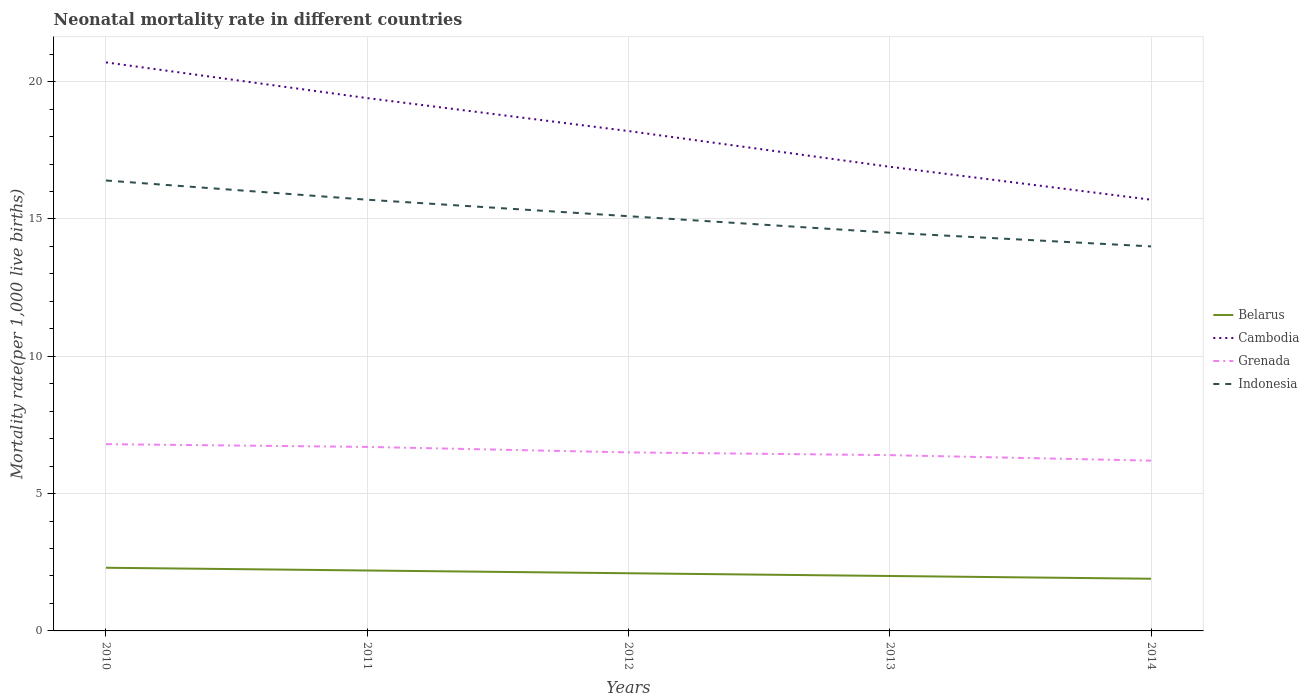How many different coloured lines are there?
Provide a succinct answer. 4. Across all years, what is the maximum neonatal mortality rate in Belarus?
Your answer should be compact. 1.9. In which year was the neonatal mortality rate in Grenada maximum?
Your response must be concise. 2014. What is the total neonatal mortality rate in Belarus in the graph?
Ensure brevity in your answer.  0.4. What is the difference between the highest and the second highest neonatal mortality rate in Grenada?
Give a very brief answer. 0.6. Is the neonatal mortality rate in Grenada strictly greater than the neonatal mortality rate in Indonesia over the years?
Offer a very short reply. Yes. What is the difference between two consecutive major ticks on the Y-axis?
Your answer should be very brief. 5. Are the values on the major ticks of Y-axis written in scientific E-notation?
Ensure brevity in your answer.  No. How many legend labels are there?
Keep it short and to the point. 4. How are the legend labels stacked?
Your answer should be very brief. Vertical. What is the title of the graph?
Provide a short and direct response. Neonatal mortality rate in different countries. Does "Tuvalu" appear as one of the legend labels in the graph?
Offer a terse response. No. What is the label or title of the Y-axis?
Your answer should be compact. Mortality rate(per 1,0 live births). What is the Mortality rate(per 1,000 live births) in Cambodia in 2010?
Your response must be concise. 20.7. What is the Mortality rate(per 1,000 live births) of Belarus in 2011?
Provide a short and direct response. 2.2. What is the Mortality rate(per 1,000 live births) in Grenada in 2011?
Offer a very short reply. 6.7. What is the Mortality rate(per 1,000 live births) of Indonesia in 2011?
Offer a very short reply. 15.7. What is the Mortality rate(per 1,000 live births) in Cambodia in 2012?
Make the answer very short. 18.2. What is the Mortality rate(per 1,000 live births) of Indonesia in 2012?
Give a very brief answer. 15.1. What is the Mortality rate(per 1,000 live births) in Belarus in 2013?
Keep it short and to the point. 2. What is the Mortality rate(per 1,000 live births) of Grenada in 2013?
Make the answer very short. 6.4. What is the Mortality rate(per 1,000 live births) in Cambodia in 2014?
Offer a very short reply. 15.7. Across all years, what is the maximum Mortality rate(per 1,000 live births) of Cambodia?
Your response must be concise. 20.7. Across all years, what is the minimum Mortality rate(per 1,000 live births) in Cambodia?
Give a very brief answer. 15.7. Across all years, what is the minimum Mortality rate(per 1,000 live births) of Grenada?
Offer a very short reply. 6.2. Across all years, what is the minimum Mortality rate(per 1,000 live births) of Indonesia?
Keep it short and to the point. 14. What is the total Mortality rate(per 1,000 live births) in Cambodia in the graph?
Your answer should be compact. 90.9. What is the total Mortality rate(per 1,000 live births) of Grenada in the graph?
Keep it short and to the point. 32.6. What is the total Mortality rate(per 1,000 live births) of Indonesia in the graph?
Provide a succinct answer. 75.7. What is the difference between the Mortality rate(per 1,000 live births) of Cambodia in 2010 and that in 2011?
Provide a succinct answer. 1.3. What is the difference between the Mortality rate(per 1,000 live births) in Indonesia in 2010 and that in 2011?
Offer a terse response. 0.7. What is the difference between the Mortality rate(per 1,000 live births) of Belarus in 2010 and that in 2012?
Ensure brevity in your answer.  0.2. What is the difference between the Mortality rate(per 1,000 live births) in Grenada in 2010 and that in 2012?
Provide a succinct answer. 0.3. What is the difference between the Mortality rate(per 1,000 live births) in Indonesia in 2010 and that in 2013?
Provide a short and direct response. 1.9. What is the difference between the Mortality rate(per 1,000 live births) in Indonesia in 2010 and that in 2014?
Ensure brevity in your answer.  2.4. What is the difference between the Mortality rate(per 1,000 live births) in Belarus in 2011 and that in 2013?
Provide a succinct answer. 0.2. What is the difference between the Mortality rate(per 1,000 live births) of Cambodia in 2011 and that in 2013?
Provide a succinct answer. 2.5. What is the difference between the Mortality rate(per 1,000 live births) of Indonesia in 2011 and that in 2013?
Your answer should be compact. 1.2. What is the difference between the Mortality rate(per 1,000 live births) in Belarus in 2011 and that in 2014?
Make the answer very short. 0.3. What is the difference between the Mortality rate(per 1,000 live births) of Cambodia in 2011 and that in 2014?
Your answer should be compact. 3.7. What is the difference between the Mortality rate(per 1,000 live births) of Indonesia in 2011 and that in 2014?
Give a very brief answer. 1.7. What is the difference between the Mortality rate(per 1,000 live births) in Cambodia in 2012 and that in 2013?
Offer a terse response. 1.3. What is the difference between the Mortality rate(per 1,000 live births) of Grenada in 2012 and that in 2013?
Make the answer very short. 0.1. What is the difference between the Mortality rate(per 1,000 live births) in Indonesia in 2012 and that in 2013?
Provide a succinct answer. 0.6. What is the difference between the Mortality rate(per 1,000 live births) of Cambodia in 2012 and that in 2014?
Provide a short and direct response. 2.5. What is the difference between the Mortality rate(per 1,000 live births) of Grenada in 2012 and that in 2014?
Keep it short and to the point. 0.3. What is the difference between the Mortality rate(per 1,000 live births) in Belarus in 2013 and that in 2014?
Your answer should be compact. 0.1. What is the difference between the Mortality rate(per 1,000 live births) of Grenada in 2013 and that in 2014?
Keep it short and to the point. 0.2. What is the difference between the Mortality rate(per 1,000 live births) in Belarus in 2010 and the Mortality rate(per 1,000 live births) in Cambodia in 2011?
Keep it short and to the point. -17.1. What is the difference between the Mortality rate(per 1,000 live births) in Belarus in 2010 and the Mortality rate(per 1,000 live births) in Grenada in 2011?
Your answer should be very brief. -4.4. What is the difference between the Mortality rate(per 1,000 live births) of Belarus in 2010 and the Mortality rate(per 1,000 live births) of Indonesia in 2011?
Ensure brevity in your answer.  -13.4. What is the difference between the Mortality rate(per 1,000 live births) in Cambodia in 2010 and the Mortality rate(per 1,000 live births) in Grenada in 2011?
Your response must be concise. 14. What is the difference between the Mortality rate(per 1,000 live births) of Cambodia in 2010 and the Mortality rate(per 1,000 live births) of Indonesia in 2011?
Make the answer very short. 5. What is the difference between the Mortality rate(per 1,000 live births) in Grenada in 2010 and the Mortality rate(per 1,000 live births) in Indonesia in 2011?
Your answer should be very brief. -8.9. What is the difference between the Mortality rate(per 1,000 live births) of Belarus in 2010 and the Mortality rate(per 1,000 live births) of Cambodia in 2012?
Offer a very short reply. -15.9. What is the difference between the Mortality rate(per 1,000 live births) in Belarus in 2010 and the Mortality rate(per 1,000 live births) in Grenada in 2012?
Ensure brevity in your answer.  -4.2. What is the difference between the Mortality rate(per 1,000 live births) in Cambodia in 2010 and the Mortality rate(per 1,000 live births) in Grenada in 2012?
Offer a terse response. 14.2. What is the difference between the Mortality rate(per 1,000 live births) in Grenada in 2010 and the Mortality rate(per 1,000 live births) in Indonesia in 2012?
Offer a terse response. -8.3. What is the difference between the Mortality rate(per 1,000 live births) of Belarus in 2010 and the Mortality rate(per 1,000 live births) of Cambodia in 2013?
Offer a terse response. -14.6. What is the difference between the Mortality rate(per 1,000 live births) in Belarus in 2010 and the Mortality rate(per 1,000 live births) in Grenada in 2013?
Provide a succinct answer. -4.1. What is the difference between the Mortality rate(per 1,000 live births) in Belarus in 2010 and the Mortality rate(per 1,000 live births) in Indonesia in 2013?
Give a very brief answer. -12.2. What is the difference between the Mortality rate(per 1,000 live births) in Cambodia in 2010 and the Mortality rate(per 1,000 live births) in Grenada in 2013?
Your answer should be compact. 14.3. What is the difference between the Mortality rate(per 1,000 live births) of Cambodia in 2010 and the Mortality rate(per 1,000 live births) of Indonesia in 2013?
Give a very brief answer. 6.2. What is the difference between the Mortality rate(per 1,000 live births) in Belarus in 2010 and the Mortality rate(per 1,000 live births) in Cambodia in 2014?
Keep it short and to the point. -13.4. What is the difference between the Mortality rate(per 1,000 live births) of Belarus in 2010 and the Mortality rate(per 1,000 live births) of Grenada in 2014?
Ensure brevity in your answer.  -3.9. What is the difference between the Mortality rate(per 1,000 live births) in Belarus in 2010 and the Mortality rate(per 1,000 live births) in Indonesia in 2014?
Give a very brief answer. -11.7. What is the difference between the Mortality rate(per 1,000 live births) in Cambodia in 2010 and the Mortality rate(per 1,000 live births) in Indonesia in 2014?
Provide a succinct answer. 6.7. What is the difference between the Mortality rate(per 1,000 live births) of Belarus in 2011 and the Mortality rate(per 1,000 live births) of Grenada in 2012?
Provide a short and direct response. -4.3. What is the difference between the Mortality rate(per 1,000 live births) of Belarus in 2011 and the Mortality rate(per 1,000 live births) of Indonesia in 2012?
Provide a succinct answer. -12.9. What is the difference between the Mortality rate(per 1,000 live births) of Belarus in 2011 and the Mortality rate(per 1,000 live births) of Cambodia in 2013?
Your answer should be compact. -14.7. What is the difference between the Mortality rate(per 1,000 live births) of Belarus in 2011 and the Mortality rate(per 1,000 live births) of Grenada in 2013?
Ensure brevity in your answer.  -4.2. What is the difference between the Mortality rate(per 1,000 live births) in Belarus in 2011 and the Mortality rate(per 1,000 live births) in Indonesia in 2013?
Your answer should be very brief. -12.3. What is the difference between the Mortality rate(per 1,000 live births) in Cambodia in 2011 and the Mortality rate(per 1,000 live births) in Indonesia in 2013?
Offer a terse response. 4.9. What is the difference between the Mortality rate(per 1,000 live births) of Grenada in 2011 and the Mortality rate(per 1,000 live births) of Indonesia in 2013?
Keep it short and to the point. -7.8. What is the difference between the Mortality rate(per 1,000 live births) in Belarus in 2011 and the Mortality rate(per 1,000 live births) in Grenada in 2014?
Your answer should be very brief. -4. What is the difference between the Mortality rate(per 1,000 live births) in Belarus in 2011 and the Mortality rate(per 1,000 live births) in Indonesia in 2014?
Your answer should be compact. -11.8. What is the difference between the Mortality rate(per 1,000 live births) of Cambodia in 2011 and the Mortality rate(per 1,000 live births) of Grenada in 2014?
Offer a very short reply. 13.2. What is the difference between the Mortality rate(per 1,000 live births) of Cambodia in 2011 and the Mortality rate(per 1,000 live births) of Indonesia in 2014?
Make the answer very short. 5.4. What is the difference between the Mortality rate(per 1,000 live births) of Belarus in 2012 and the Mortality rate(per 1,000 live births) of Cambodia in 2013?
Give a very brief answer. -14.8. What is the difference between the Mortality rate(per 1,000 live births) in Belarus in 2012 and the Mortality rate(per 1,000 live births) in Grenada in 2013?
Provide a short and direct response. -4.3. What is the difference between the Mortality rate(per 1,000 live births) of Cambodia in 2012 and the Mortality rate(per 1,000 live births) of Grenada in 2013?
Make the answer very short. 11.8. What is the difference between the Mortality rate(per 1,000 live births) in Cambodia in 2012 and the Mortality rate(per 1,000 live births) in Indonesia in 2013?
Provide a short and direct response. 3.7. What is the difference between the Mortality rate(per 1,000 live births) of Grenada in 2012 and the Mortality rate(per 1,000 live births) of Indonesia in 2013?
Give a very brief answer. -8. What is the difference between the Mortality rate(per 1,000 live births) of Belarus in 2012 and the Mortality rate(per 1,000 live births) of Grenada in 2014?
Offer a very short reply. -4.1. What is the difference between the Mortality rate(per 1,000 live births) of Belarus in 2012 and the Mortality rate(per 1,000 live births) of Indonesia in 2014?
Your answer should be very brief. -11.9. What is the difference between the Mortality rate(per 1,000 live births) of Grenada in 2012 and the Mortality rate(per 1,000 live births) of Indonesia in 2014?
Offer a very short reply. -7.5. What is the difference between the Mortality rate(per 1,000 live births) of Belarus in 2013 and the Mortality rate(per 1,000 live births) of Cambodia in 2014?
Make the answer very short. -13.7. What is the difference between the Mortality rate(per 1,000 live births) in Cambodia in 2013 and the Mortality rate(per 1,000 live births) in Grenada in 2014?
Make the answer very short. 10.7. What is the average Mortality rate(per 1,000 live births) in Belarus per year?
Provide a succinct answer. 2.1. What is the average Mortality rate(per 1,000 live births) of Cambodia per year?
Provide a succinct answer. 18.18. What is the average Mortality rate(per 1,000 live births) in Grenada per year?
Your answer should be very brief. 6.52. What is the average Mortality rate(per 1,000 live births) of Indonesia per year?
Offer a very short reply. 15.14. In the year 2010, what is the difference between the Mortality rate(per 1,000 live births) in Belarus and Mortality rate(per 1,000 live births) in Cambodia?
Your answer should be very brief. -18.4. In the year 2010, what is the difference between the Mortality rate(per 1,000 live births) in Belarus and Mortality rate(per 1,000 live births) in Indonesia?
Provide a succinct answer. -14.1. In the year 2010, what is the difference between the Mortality rate(per 1,000 live births) of Cambodia and Mortality rate(per 1,000 live births) of Grenada?
Ensure brevity in your answer.  13.9. In the year 2010, what is the difference between the Mortality rate(per 1,000 live births) in Cambodia and Mortality rate(per 1,000 live births) in Indonesia?
Your answer should be compact. 4.3. In the year 2010, what is the difference between the Mortality rate(per 1,000 live births) in Grenada and Mortality rate(per 1,000 live births) in Indonesia?
Offer a terse response. -9.6. In the year 2011, what is the difference between the Mortality rate(per 1,000 live births) in Belarus and Mortality rate(per 1,000 live births) in Cambodia?
Offer a terse response. -17.2. In the year 2011, what is the difference between the Mortality rate(per 1,000 live births) of Belarus and Mortality rate(per 1,000 live births) of Grenada?
Give a very brief answer. -4.5. In the year 2011, what is the difference between the Mortality rate(per 1,000 live births) of Belarus and Mortality rate(per 1,000 live births) of Indonesia?
Offer a very short reply. -13.5. In the year 2011, what is the difference between the Mortality rate(per 1,000 live births) of Cambodia and Mortality rate(per 1,000 live births) of Grenada?
Provide a short and direct response. 12.7. In the year 2011, what is the difference between the Mortality rate(per 1,000 live births) of Cambodia and Mortality rate(per 1,000 live births) of Indonesia?
Ensure brevity in your answer.  3.7. In the year 2011, what is the difference between the Mortality rate(per 1,000 live births) in Grenada and Mortality rate(per 1,000 live births) in Indonesia?
Offer a very short reply. -9. In the year 2012, what is the difference between the Mortality rate(per 1,000 live births) in Belarus and Mortality rate(per 1,000 live births) in Cambodia?
Keep it short and to the point. -16.1. In the year 2012, what is the difference between the Mortality rate(per 1,000 live births) of Belarus and Mortality rate(per 1,000 live births) of Grenada?
Your response must be concise. -4.4. In the year 2012, what is the difference between the Mortality rate(per 1,000 live births) of Cambodia and Mortality rate(per 1,000 live births) of Grenada?
Keep it short and to the point. 11.7. In the year 2012, what is the difference between the Mortality rate(per 1,000 live births) of Cambodia and Mortality rate(per 1,000 live births) of Indonesia?
Your answer should be very brief. 3.1. In the year 2013, what is the difference between the Mortality rate(per 1,000 live births) in Belarus and Mortality rate(per 1,000 live births) in Cambodia?
Provide a short and direct response. -14.9. In the year 2013, what is the difference between the Mortality rate(per 1,000 live births) of Belarus and Mortality rate(per 1,000 live births) of Grenada?
Ensure brevity in your answer.  -4.4. In the year 2013, what is the difference between the Mortality rate(per 1,000 live births) of Belarus and Mortality rate(per 1,000 live births) of Indonesia?
Offer a terse response. -12.5. In the year 2013, what is the difference between the Mortality rate(per 1,000 live births) in Cambodia and Mortality rate(per 1,000 live births) in Indonesia?
Your answer should be very brief. 2.4. In the year 2014, what is the difference between the Mortality rate(per 1,000 live births) of Belarus and Mortality rate(per 1,000 live births) of Cambodia?
Keep it short and to the point. -13.8. In the year 2014, what is the difference between the Mortality rate(per 1,000 live births) of Belarus and Mortality rate(per 1,000 live births) of Grenada?
Offer a very short reply. -4.3. In the year 2014, what is the difference between the Mortality rate(per 1,000 live births) in Cambodia and Mortality rate(per 1,000 live births) in Grenada?
Offer a terse response. 9.5. In the year 2014, what is the difference between the Mortality rate(per 1,000 live births) in Cambodia and Mortality rate(per 1,000 live births) in Indonesia?
Keep it short and to the point. 1.7. In the year 2014, what is the difference between the Mortality rate(per 1,000 live births) in Grenada and Mortality rate(per 1,000 live births) in Indonesia?
Give a very brief answer. -7.8. What is the ratio of the Mortality rate(per 1,000 live births) in Belarus in 2010 to that in 2011?
Your answer should be very brief. 1.05. What is the ratio of the Mortality rate(per 1,000 live births) of Cambodia in 2010 to that in 2011?
Keep it short and to the point. 1.07. What is the ratio of the Mortality rate(per 1,000 live births) of Grenada in 2010 to that in 2011?
Give a very brief answer. 1.01. What is the ratio of the Mortality rate(per 1,000 live births) of Indonesia in 2010 to that in 2011?
Ensure brevity in your answer.  1.04. What is the ratio of the Mortality rate(per 1,000 live births) in Belarus in 2010 to that in 2012?
Keep it short and to the point. 1.1. What is the ratio of the Mortality rate(per 1,000 live births) in Cambodia in 2010 to that in 2012?
Give a very brief answer. 1.14. What is the ratio of the Mortality rate(per 1,000 live births) in Grenada in 2010 to that in 2012?
Make the answer very short. 1.05. What is the ratio of the Mortality rate(per 1,000 live births) in Indonesia in 2010 to that in 2012?
Keep it short and to the point. 1.09. What is the ratio of the Mortality rate(per 1,000 live births) of Belarus in 2010 to that in 2013?
Your answer should be compact. 1.15. What is the ratio of the Mortality rate(per 1,000 live births) of Cambodia in 2010 to that in 2013?
Ensure brevity in your answer.  1.22. What is the ratio of the Mortality rate(per 1,000 live births) of Indonesia in 2010 to that in 2013?
Your response must be concise. 1.13. What is the ratio of the Mortality rate(per 1,000 live births) of Belarus in 2010 to that in 2014?
Provide a succinct answer. 1.21. What is the ratio of the Mortality rate(per 1,000 live births) of Cambodia in 2010 to that in 2014?
Your response must be concise. 1.32. What is the ratio of the Mortality rate(per 1,000 live births) of Grenada in 2010 to that in 2014?
Your answer should be very brief. 1.1. What is the ratio of the Mortality rate(per 1,000 live births) in Indonesia in 2010 to that in 2014?
Give a very brief answer. 1.17. What is the ratio of the Mortality rate(per 1,000 live births) of Belarus in 2011 to that in 2012?
Give a very brief answer. 1.05. What is the ratio of the Mortality rate(per 1,000 live births) in Cambodia in 2011 to that in 2012?
Offer a terse response. 1.07. What is the ratio of the Mortality rate(per 1,000 live births) in Grenada in 2011 to that in 2012?
Your response must be concise. 1.03. What is the ratio of the Mortality rate(per 1,000 live births) of Indonesia in 2011 to that in 2012?
Offer a very short reply. 1.04. What is the ratio of the Mortality rate(per 1,000 live births) in Cambodia in 2011 to that in 2013?
Your answer should be very brief. 1.15. What is the ratio of the Mortality rate(per 1,000 live births) of Grenada in 2011 to that in 2013?
Your response must be concise. 1.05. What is the ratio of the Mortality rate(per 1,000 live births) of Indonesia in 2011 to that in 2013?
Keep it short and to the point. 1.08. What is the ratio of the Mortality rate(per 1,000 live births) in Belarus in 2011 to that in 2014?
Provide a short and direct response. 1.16. What is the ratio of the Mortality rate(per 1,000 live births) in Cambodia in 2011 to that in 2014?
Provide a succinct answer. 1.24. What is the ratio of the Mortality rate(per 1,000 live births) of Grenada in 2011 to that in 2014?
Offer a terse response. 1.08. What is the ratio of the Mortality rate(per 1,000 live births) of Indonesia in 2011 to that in 2014?
Give a very brief answer. 1.12. What is the ratio of the Mortality rate(per 1,000 live births) of Belarus in 2012 to that in 2013?
Give a very brief answer. 1.05. What is the ratio of the Mortality rate(per 1,000 live births) of Cambodia in 2012 to that in 2013?
Give a very brief answer. 1.08. What is the ratio of the Mortality rate(per 1,000 live births) in Grenada in 2012 to that in 2013?
Provide a short and direct response. 1.02. What is the ratio of the Mortality rate(per 1,000 live births) of Indonesia in 2012 to that in 2013?
Make the answer very short. 1.04. What is the ratio of the Mortality rate(per 1,000 live births) of Belarus in 2012 to that in 2014?
Provide a short and direct response. 1.11. What is the ratio of the Mortality rate(per 1,000 live births) in Cambodia in 2012 to that in 2014?
Give a very brief answer. 1.16. What is the ratio of the Mortality rate(per 1,000 live births) of Grenada in 2012 to that in 2014?
Keep it short and to the point. 1.05. What is the ratio of the Mortality rate(per 1,000 live births) of Indonesia in 2012 to that in 2014?
Make the answer very short. 1.08. What is the ratio of the Mortality rate(per 1,000 live births) in Belarus in 2013 to that in 2014?
Ensure brevity in your answer.  1.05. What is the ratio of the Mortality rate(per 1,000 live births) of Cambodia in 2013 to that in 2014?
Give a very brief answer. 1.08. What is the ratio of the Mortality rate(per 1,000 live births) of Grenada in 2013 to that in 2014?
Give a very brief answer. 1.03. What is the ratio of the Mortality rate(per 1,000 live births) of Indonesia in 2013 to that in 2014?
Your response must be concise. 1.04. What is the difference between the highest and the second highest Mortality rate(per 1,000 live births) of Cambodia?
Keep it short and to the point. 1.3. What is the difference between the highest and the second highest Mortality rate(per 1,000 live births) in Indonesia?
Keep it short and to the point. 0.7. What is the difference between the highest and the lowest Mortality rate(per 1,000 live births) in Belarus?
Ensure brevity in your answer.  0.4. What is the difference between the highest and the lowest Mortality rate(per 1,000 live births) of Cambodia?
Keep it short and to the point. 5. What is the difference between the highest and the lowest Mortality rate(per 1,000 live births) of Indonesia?
Ensure brevity in your answer.  2.4. 